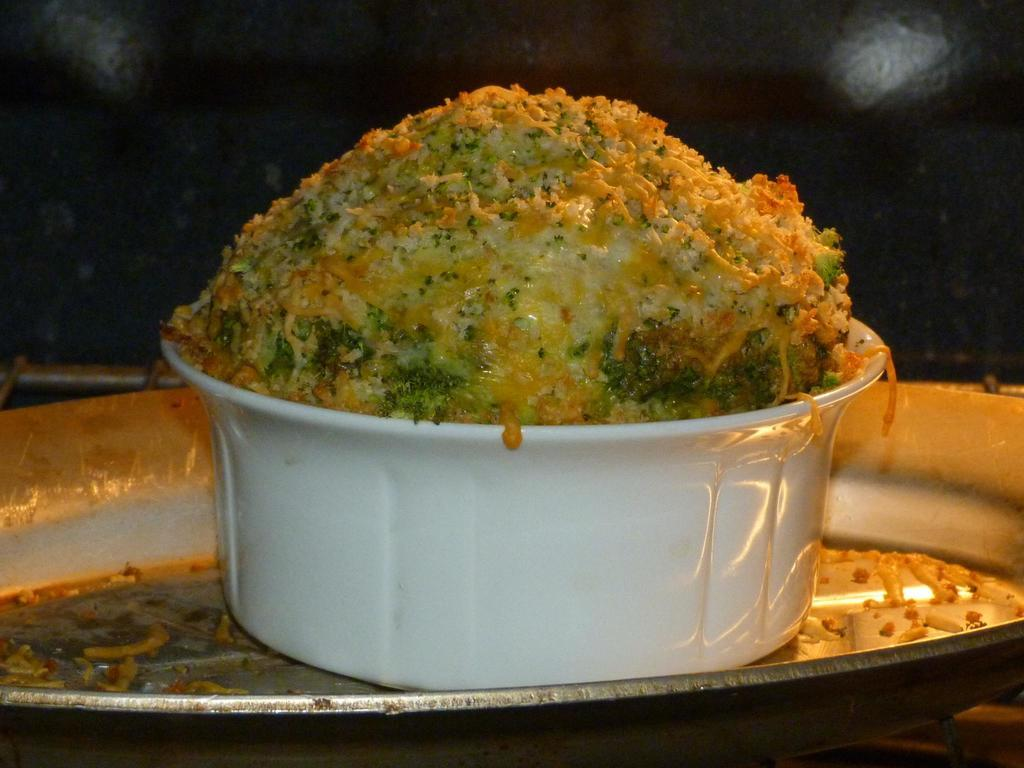What color is the bowl containing the food item in the image? The bowl is white. How is the bowl positioned in relation to the plate? The bowl is kept on a plate. What can be observed about the background of the image? The background of the image is dark. What type of tail can be seen on the food item in the image? There is no tail present on the food item in the image. What might be happening in the class depicted in the image? There is no class depicted in the image; it features a bowl of food on a plate with a dark background. 